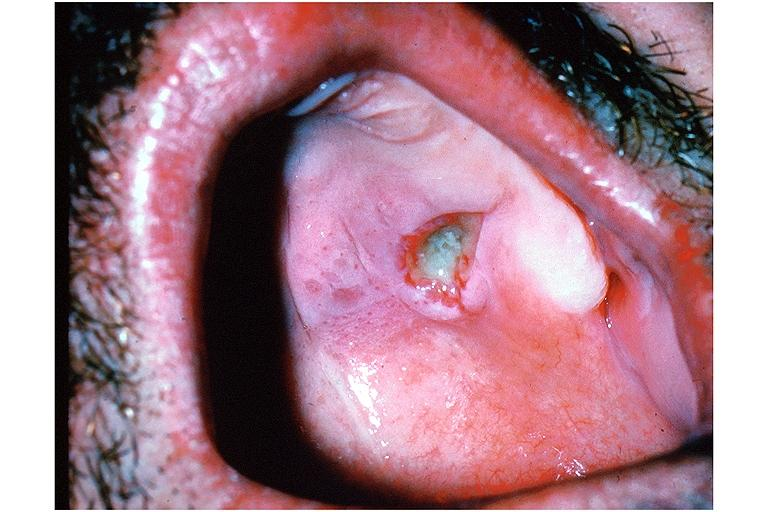what is present?
Answer the question using a single word or phrase. Oral 